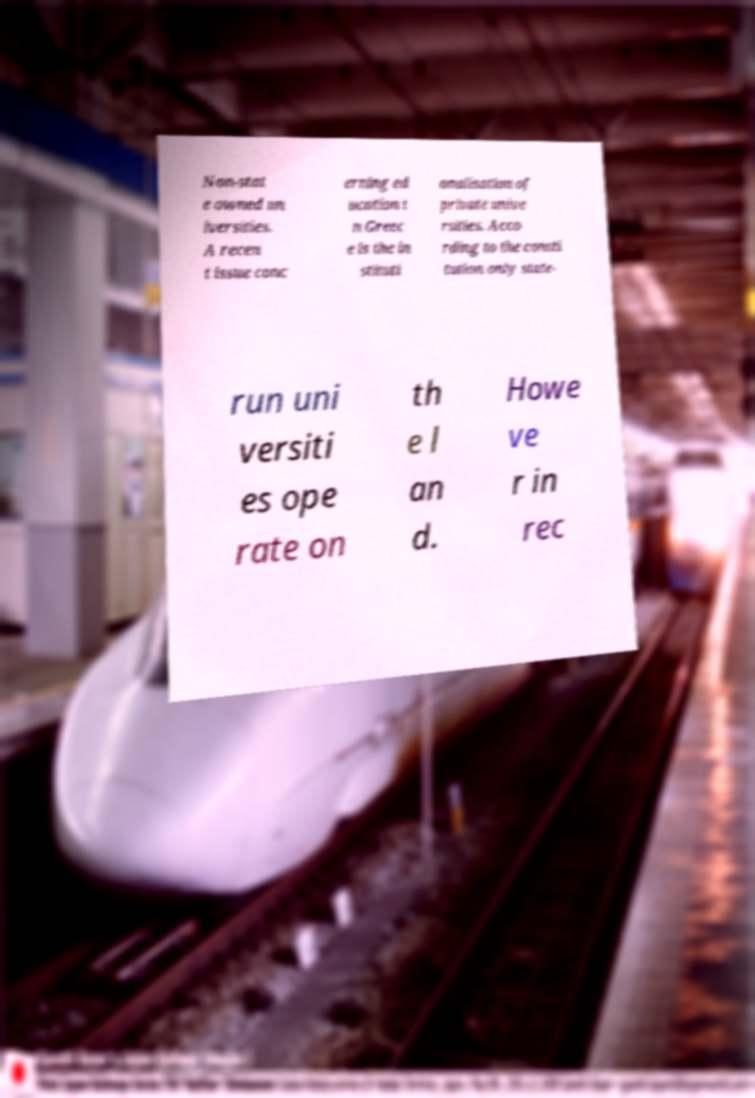Can you read and provide the text displayed in the image?This photo seems to have some interesting text. Can you extract and type it out for me? Non-stat e owned un iversities. A recen t issue conc erning ed ucation i n Greec e is the in stituti onalisation of private unive rsities. Acco rding to the consti tution only state- run uni versiti es ope rate on th e l an d. Howe ve r in rec 